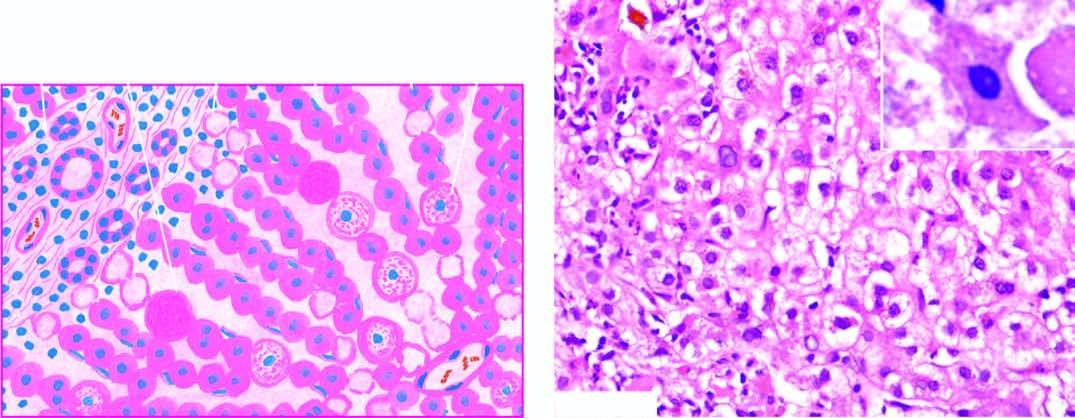re acidophilic councilman bodies indicative of more severe liver cell injury?
Answer the question using a single word or phrase. Yes 